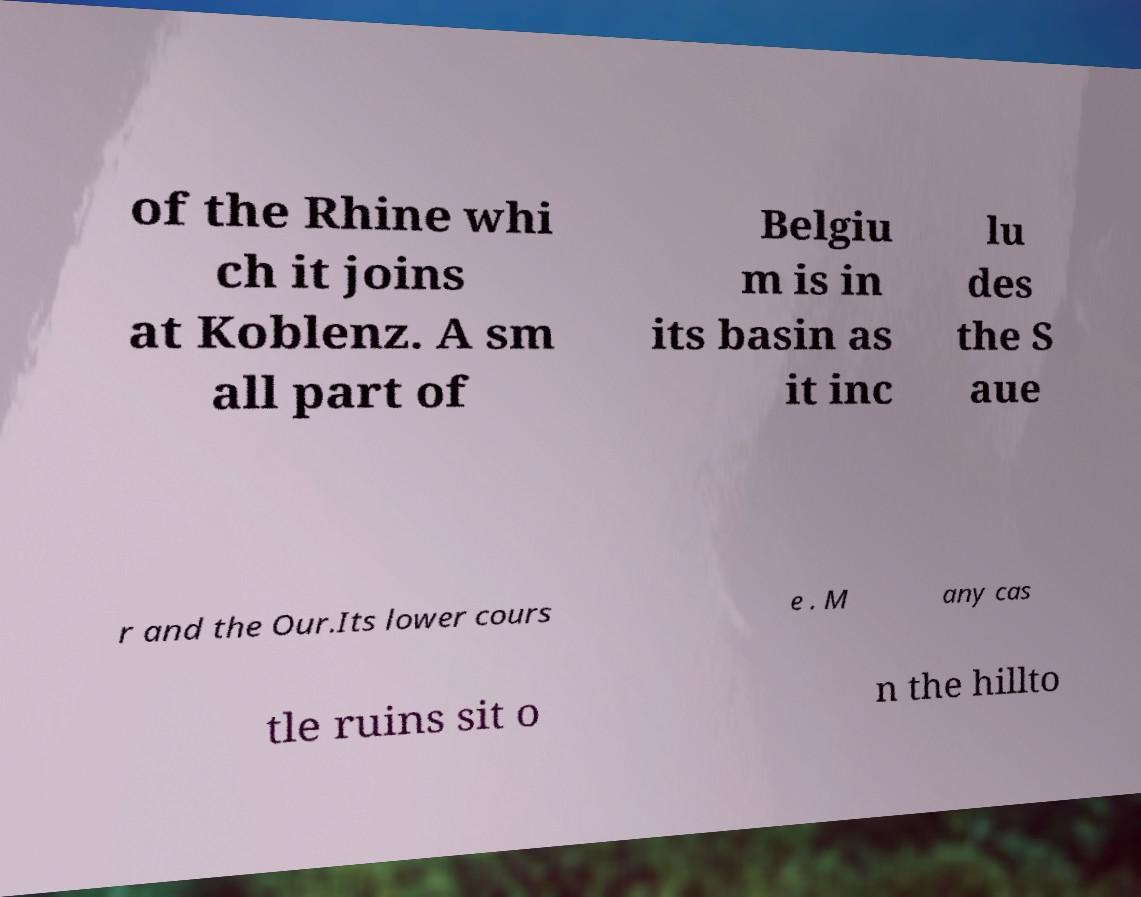What messages or text are displayed in this image? I need them in a readable, typed format. of the Rhine whi ch it joins at Koblenz. A sm all part of Belgiu m is in its basin as it inc lu des the S aue r and the Our.Its lower cours e . M any cas tle ruins sit o n the hillto 